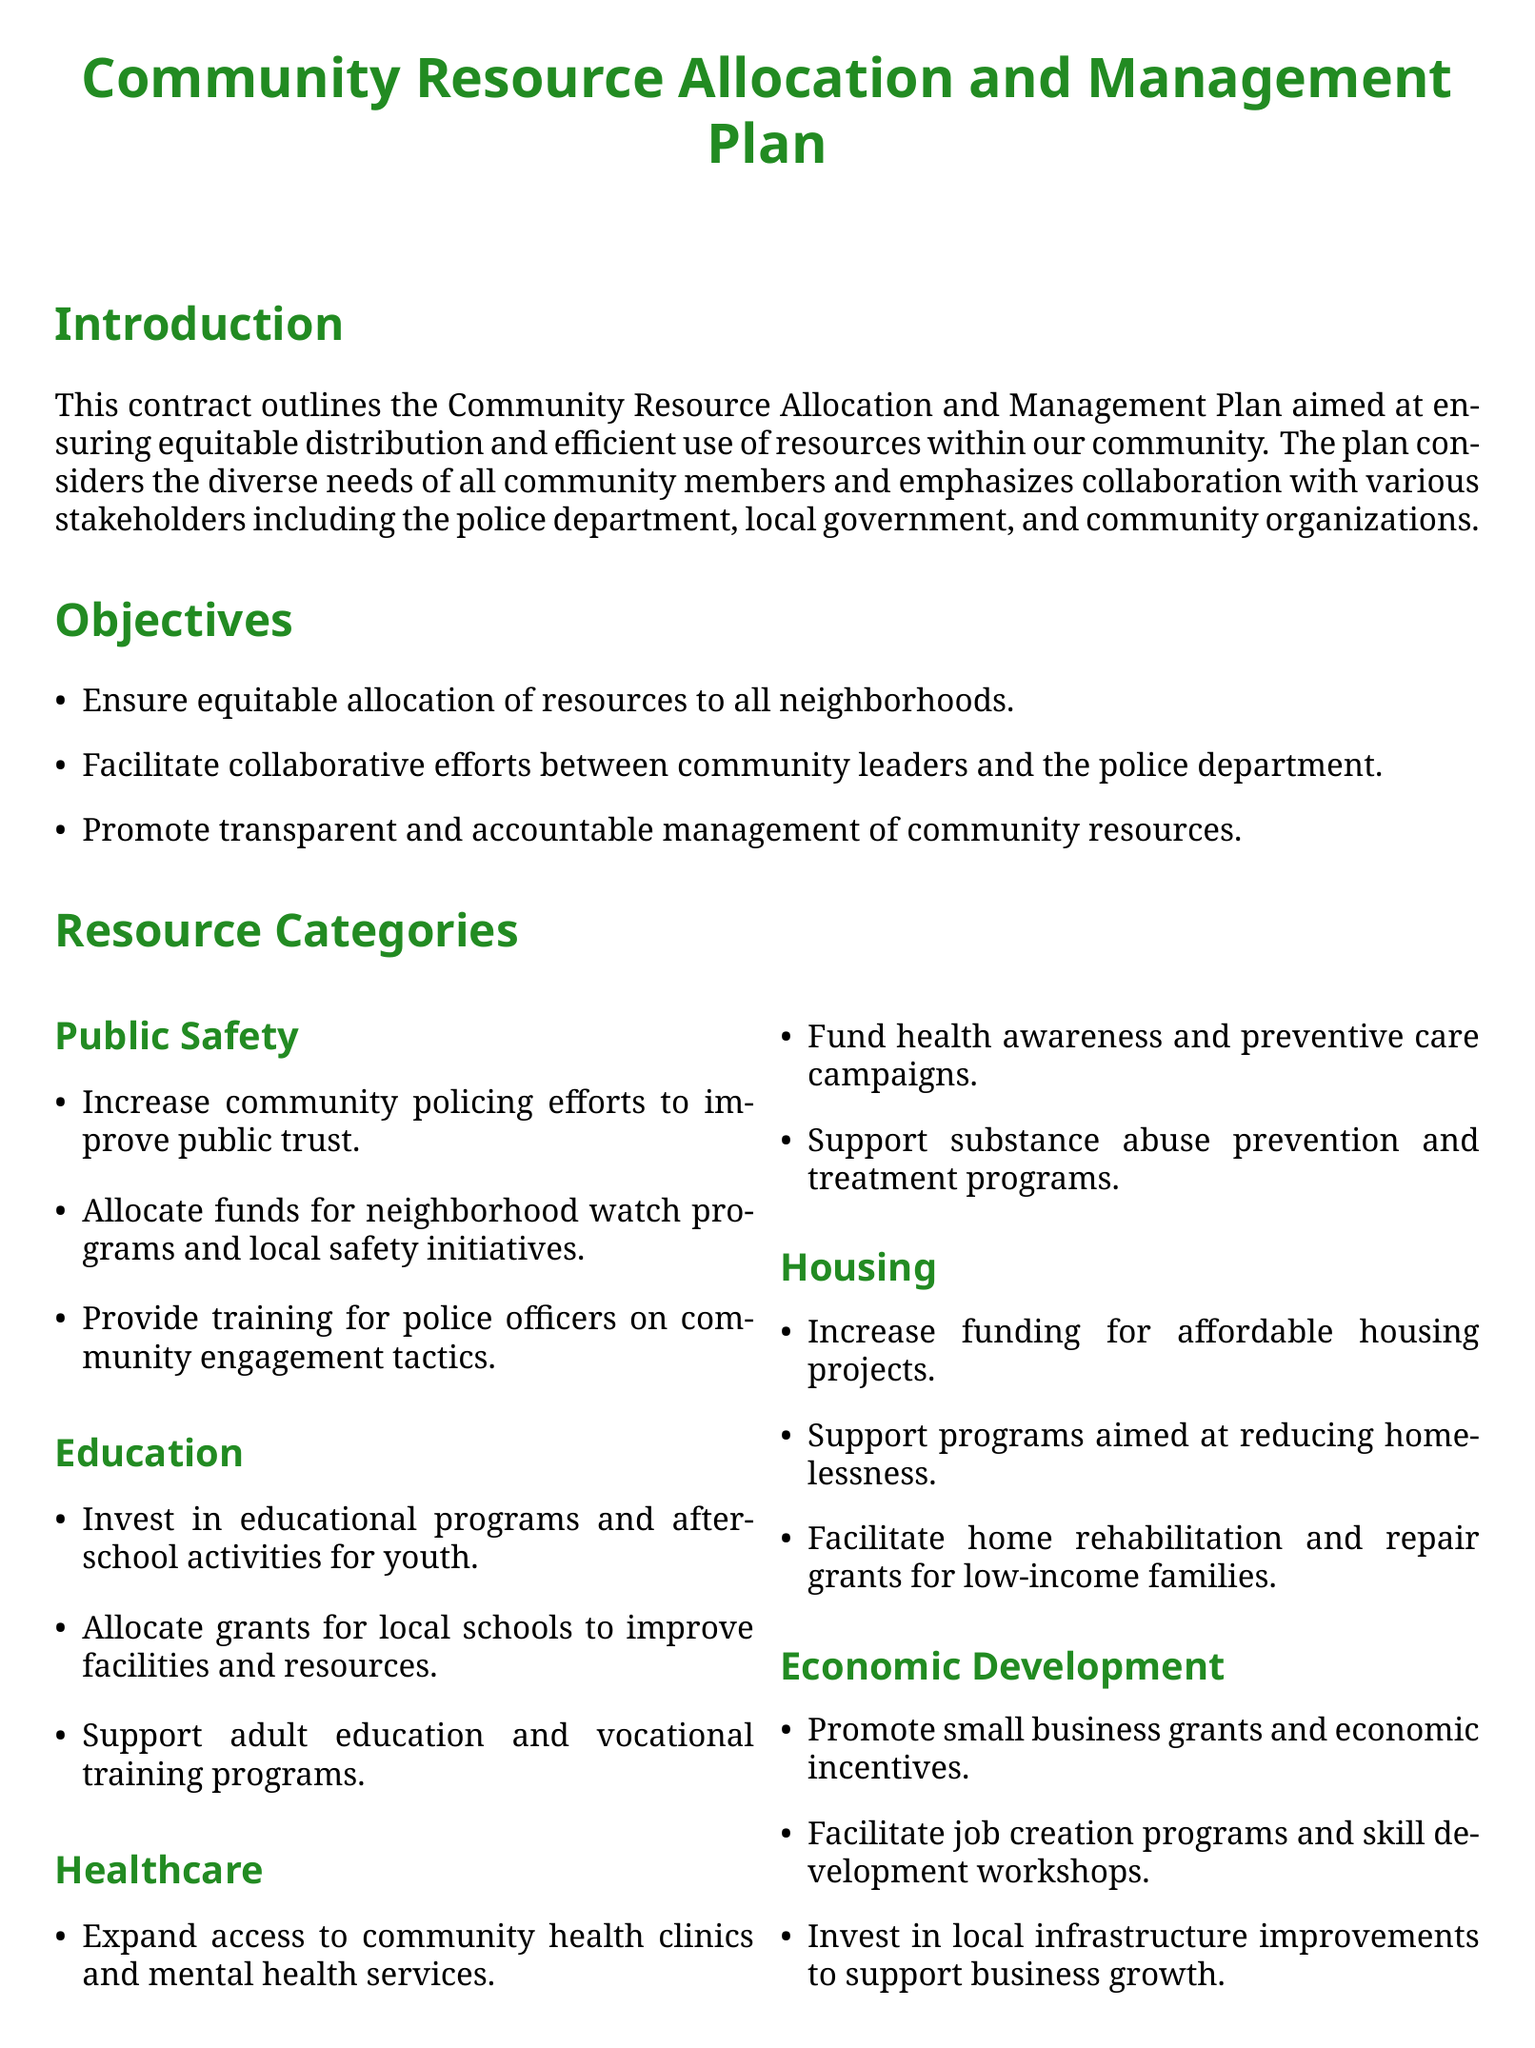What is the title of the document? The title is stated at the top of the document as the main heading.
Answer: Community Resource Allocation and Management Plan What is one of the objectives of the plan? One of the objectives is listed in the Objectives section.
Answer: Ensure equitable allocation of resources to all neighborhoods Which category includes funds for neighborhood watch programs? This question pertains to the Resource Categories section detailing public safety initiatives.
Answer: Public Safety Who is responsible for overseeing the distribution of funds? The responsibilities of stakeholders are laid out in the document, identifying who oversees funds.
Answer: Local Government How many resource categories are listed? The document outlines multiple categories in the Resource Categories section.
Answer: Five What will be established to provide oversight on resource utilization? This is found in the Evaluation and Accountability section discussing community oversight.
Answer: A community advisory board What stakeholder is responsible for engaging in community-based policing? The responsibilities of different stakeholders include specific roles related to community policing.
Answer: Police Department What type of training is mentioned for police officers? This is specified under the Public Safety category regarding police engagement.
Answer: Training for police officers on community engagement tactics What is the signature requirement for the document? This question relates to the signature section of the contract indicating who must sign it.
Answer: The undersigned agree to the terms and objectives outlined 